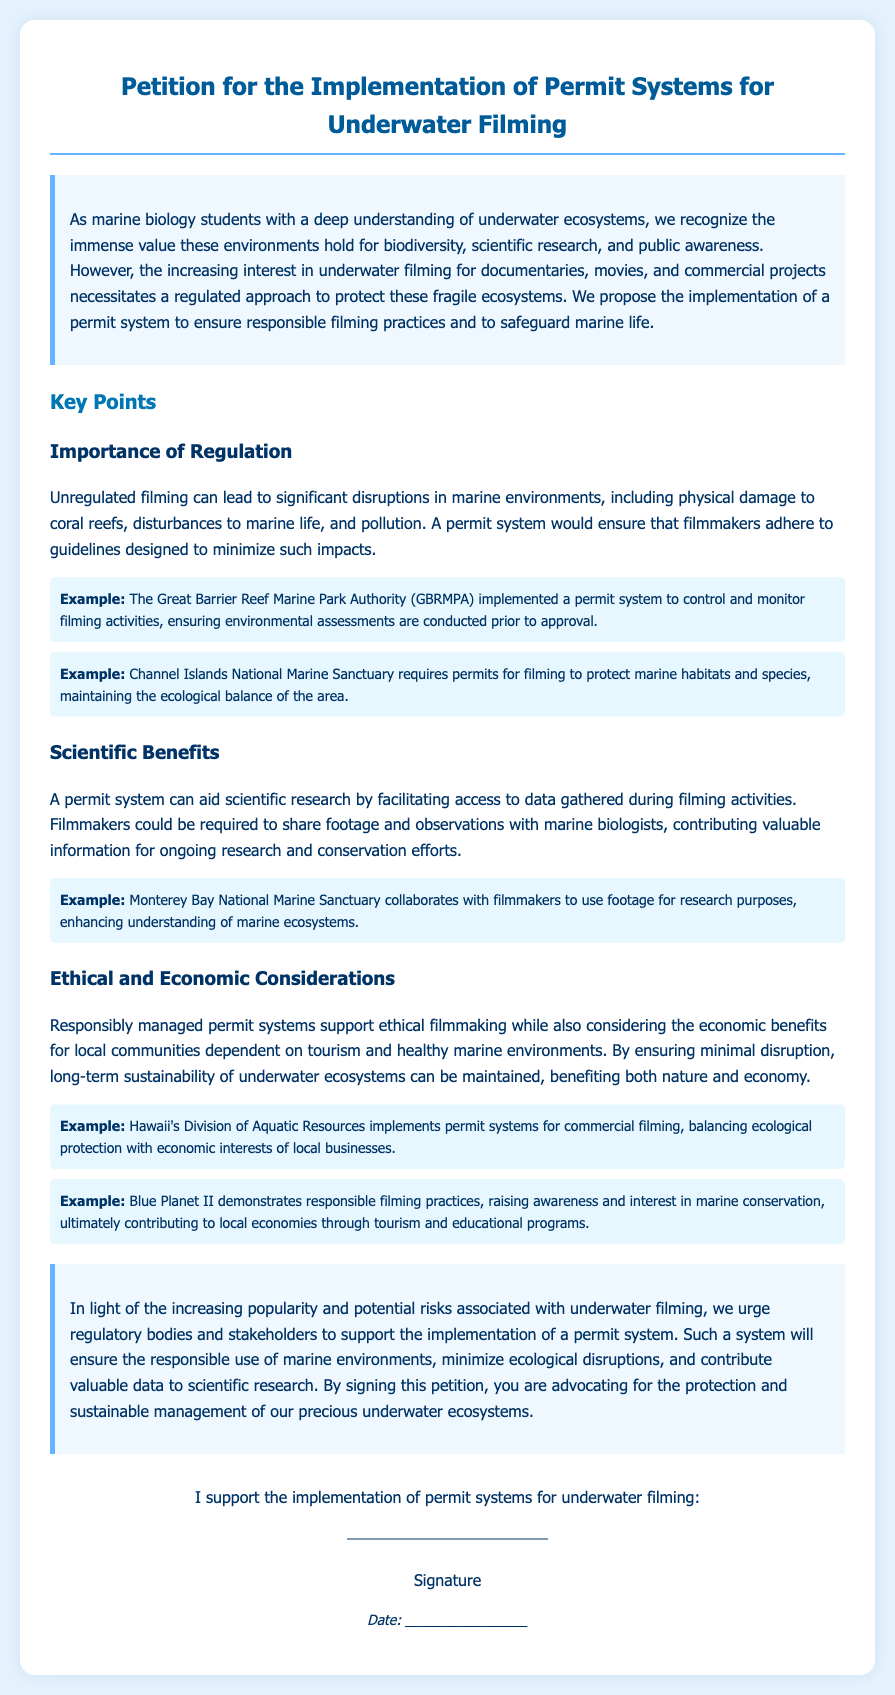What is the title of the petition? The title of the petition is clearly stated at the top of the document.
Answer: Petition for the Implementation of Permit Systems for Underwater Filming What does the introduction emphasize? The introduction highlights the need for a regulated approach to protect fragile marine ecosystems.
Answer: Regulated approach to protect fragile ecosystems How many key points are mentioned in the document? The document lists three main key points regarding the permit system.
Answer: Three Which organization implemented a permit system for the Great Barrier Reef? The document provides an example of an organization that has put a permit system in place.
Answer: GBRMPA What is one example of a sanctuary that requires permits for filming? The document includes examples of various sanctuaries that necessitate permits for underwater filming.
Answer: Channel Islands National Marine Sanctuary What is a scientific benefit of the proposed permit system? The document states a specific way the permit system can aid scientific research.
Answer: Facilitating access to data What does the conclusion urge regulatory bodies to do? The conclusion summarizes the action the petition advocates for.
Answer: Support the implementation of a permit system What is the purpose of the signature section? The signature section serves a specific function within the document's structure.
Answer: To gather support for the petition 